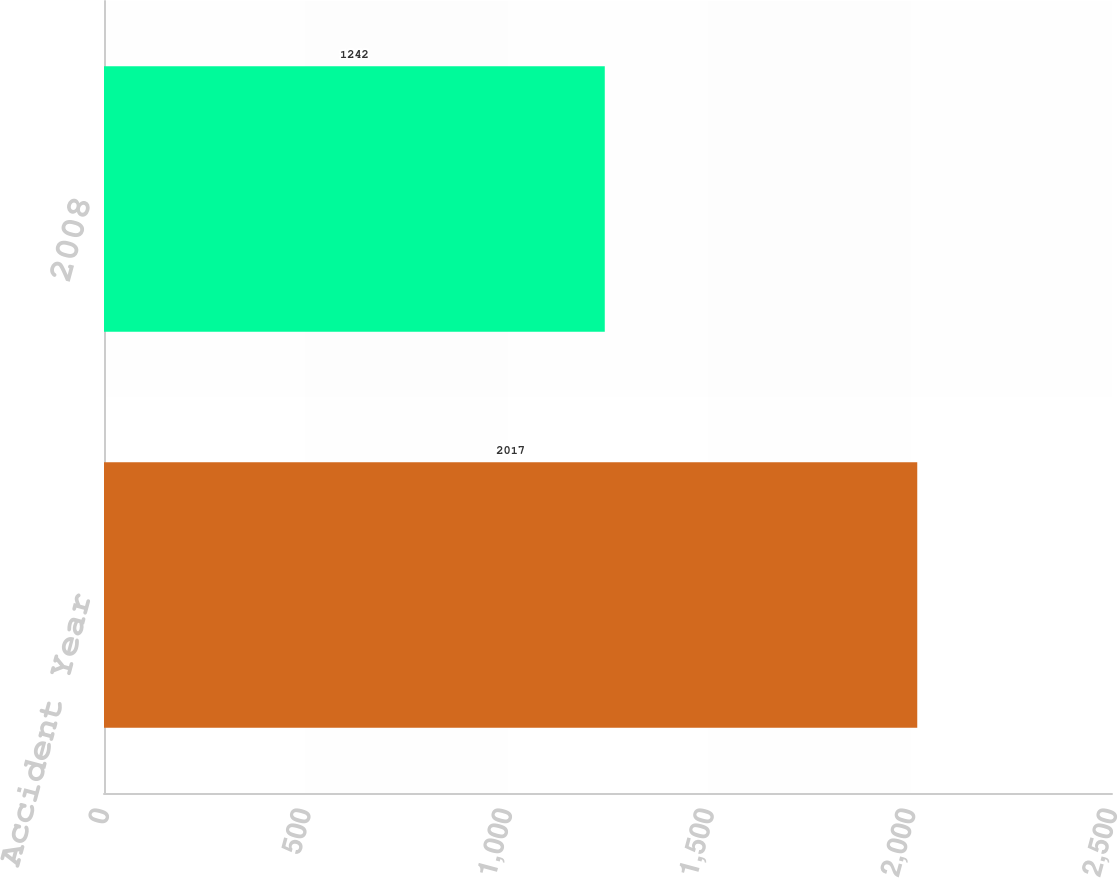Convert chart to OTSL. <chart><loc_0><loc_0><loc_500><loc_500><bar_chart><fcel>Accident Year<fcel>2008<nl><fcel>2017<fcel>1242<nl></chart> 